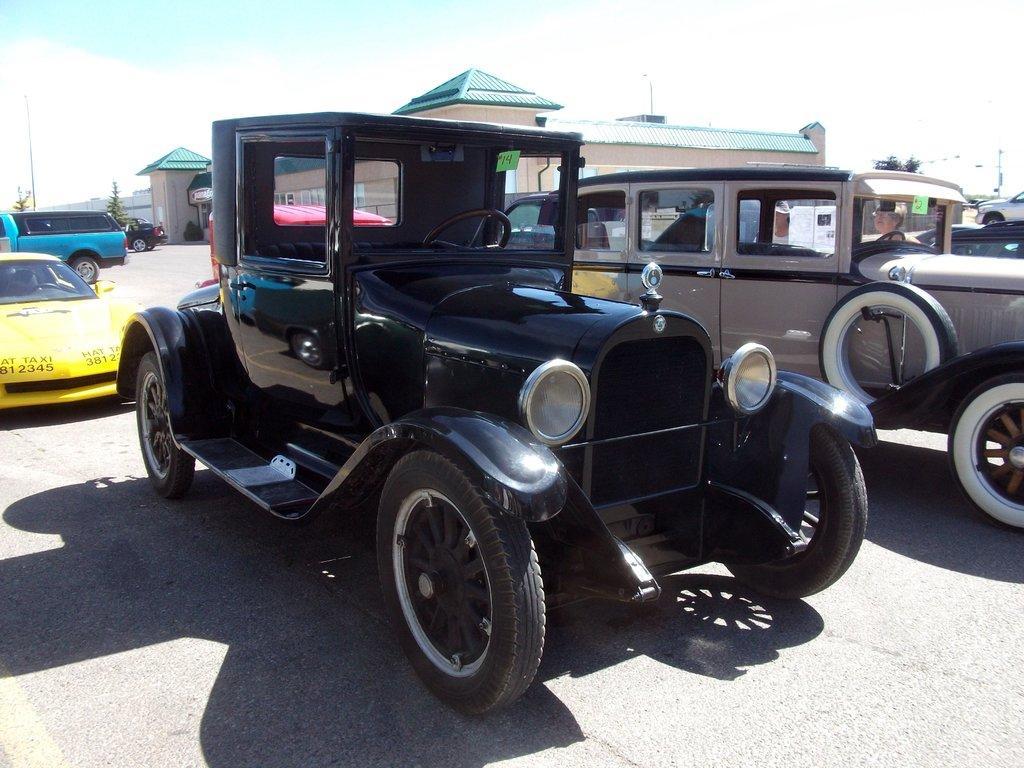In one or two sentences, can you explain what this image depicts? There is a vehicle in the foreground area of the image, there are vehicles, houses, plants and the sky in the background. 